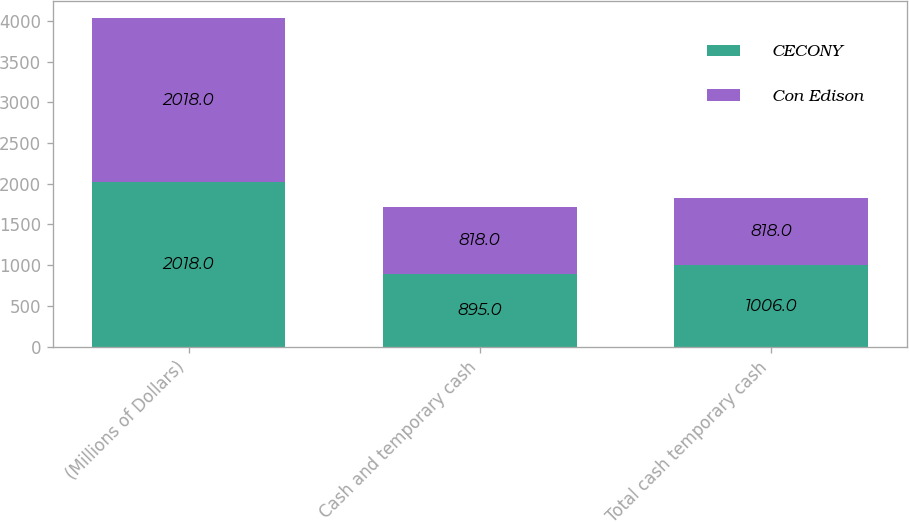Convert chart. <chart><loc_0><loc_0><loc_500><loc_500><stacked_bar_chart><ecel><fcel>(Millions of Dollars)<fcel>Cash and temporary cash<fcel>Total cash temporary cash<nl><fcel>CECONY<fcel>2018<fcel>895<fcel>1006<nl><fcel>Con Edison<fcel>2018<fcel>818<fcel>818<nl></chart> 